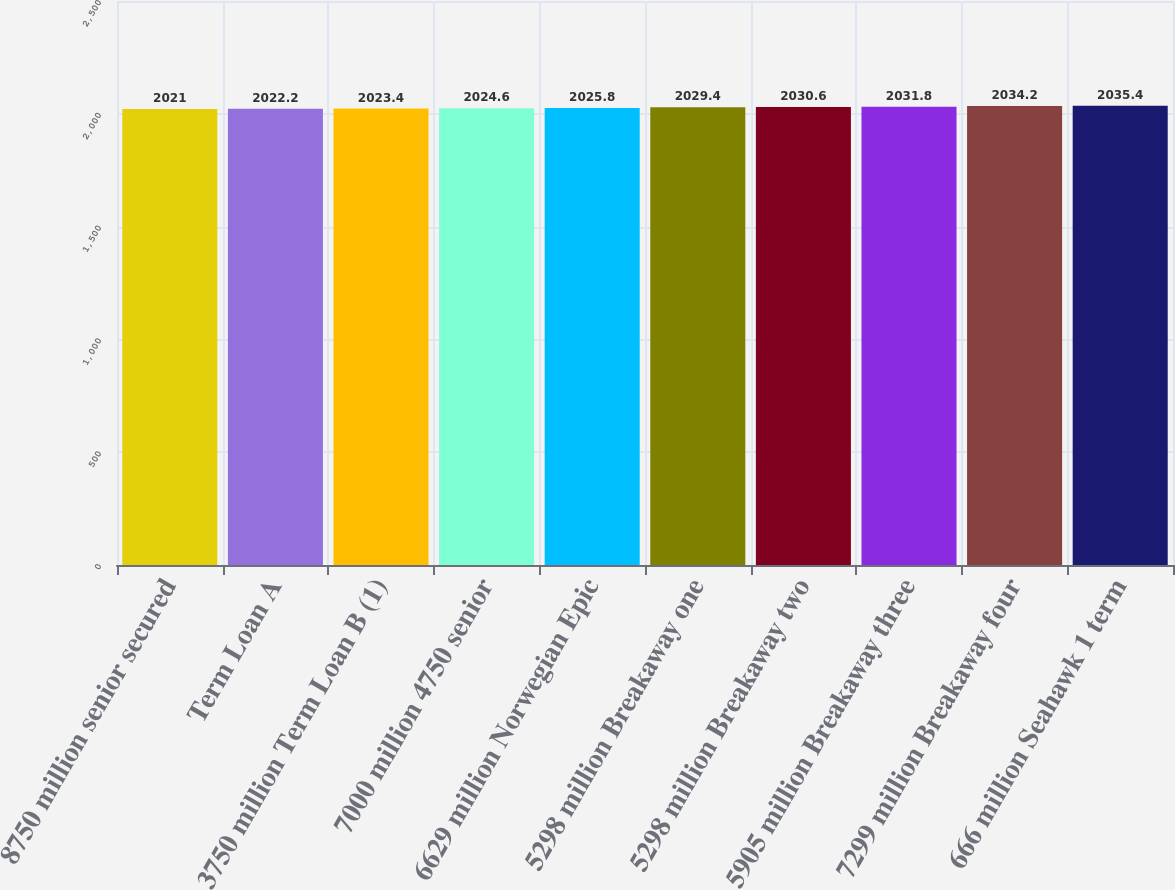Convert chart to OTSL. <chart><loc_0><loc_0><loc_500><loc_500><bar_chart><fcel>8750 million senior secured<fcel>Term Loan A<fcel>3750 million Term Loan B (1)<fcel>7000 million 4750 senior<fcel>6629 million Norwegian Epic<fcel>5298 million Breakaway one<fcel>5298 million Breakaway two<fcel>5905 million Breakaway three<fcel>7299 million Breakaway four<fcel>666 million Seahawk 1 term<nl><fcel>2021<fcel>2022.2<fcel>2023.4<fcel>2024.6<fcel>2025.8<fcel>2029.4<fcel>2030.6<fcel>2031.8<fcel>2034.2<fcel>2035.4<nl></chart> 